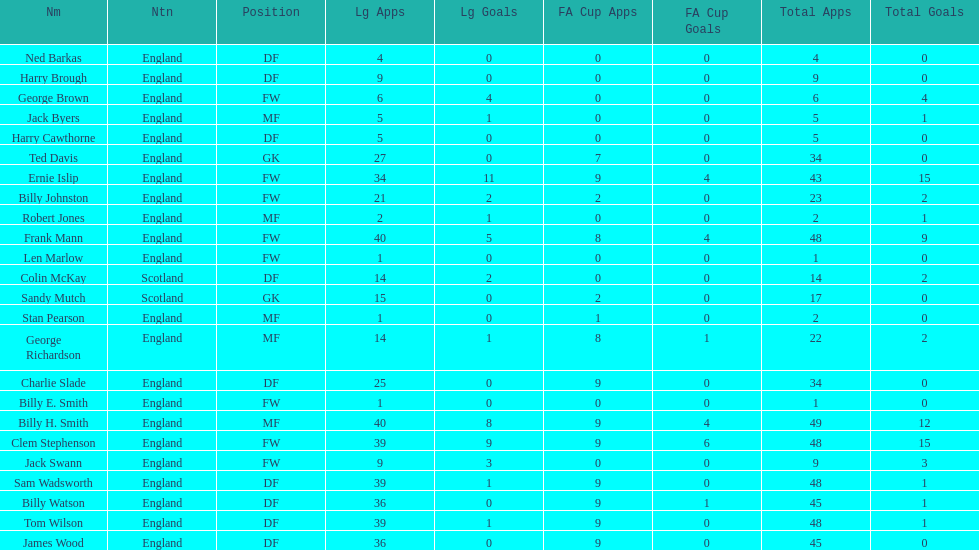The least number of total appearances 1. 